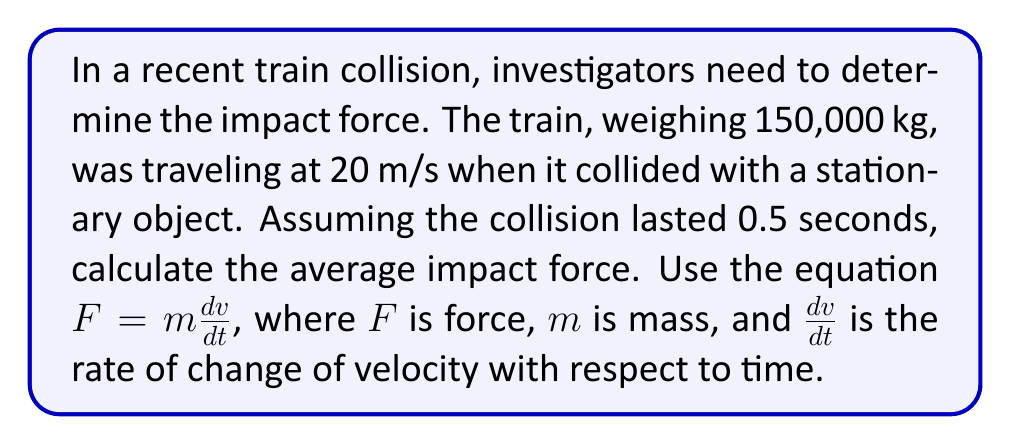Give your solution to this math problem. To solve this problem, we'll use the equation $F = m\frac{dv}{dt}$, where:

$F$ = average impact force (N)
$m$ = mass of the train (kg)
$\frac{dv}{dt}$ = rate of change of velocity with respect to time (m/s²)

Given:
- Mass of the train, $m = 150,000$ kg
- Initial velocity, $v_i = 20$ m/s
- Final velocity, $v_f = 0$ m/s (the train comes to a stop)
- Time of impact, $t = 0.5$ s

Step 1: Calculate the change in velocity (Δv)
$$\Delta v = v_f - v_i = 0 - 20 = -20 \text{ m/s}$$

Step 2: Calculate the rate of change of velocity ($\frac{dv}{dt}$)
$$\frac{dv}{dt} = \frac{\Delta v}{\Delta t} = \frac{-20}{0.5} = -40 \text{ m/s²}$$

Step 3: Apply the force equation
$$F = m\frac{dv}{dt}$$
$$F = 150,000 \times (-40)$$
$$F = -6,000,000 \text{ N}$$

The negative sign indicates that the force is in the opposite direction of the train's initial motion. We can express the magnitude of the force as 6,000,000 N or 6 MN.
Answer: The average impact force is 6,000,000 N or 6 MN. 